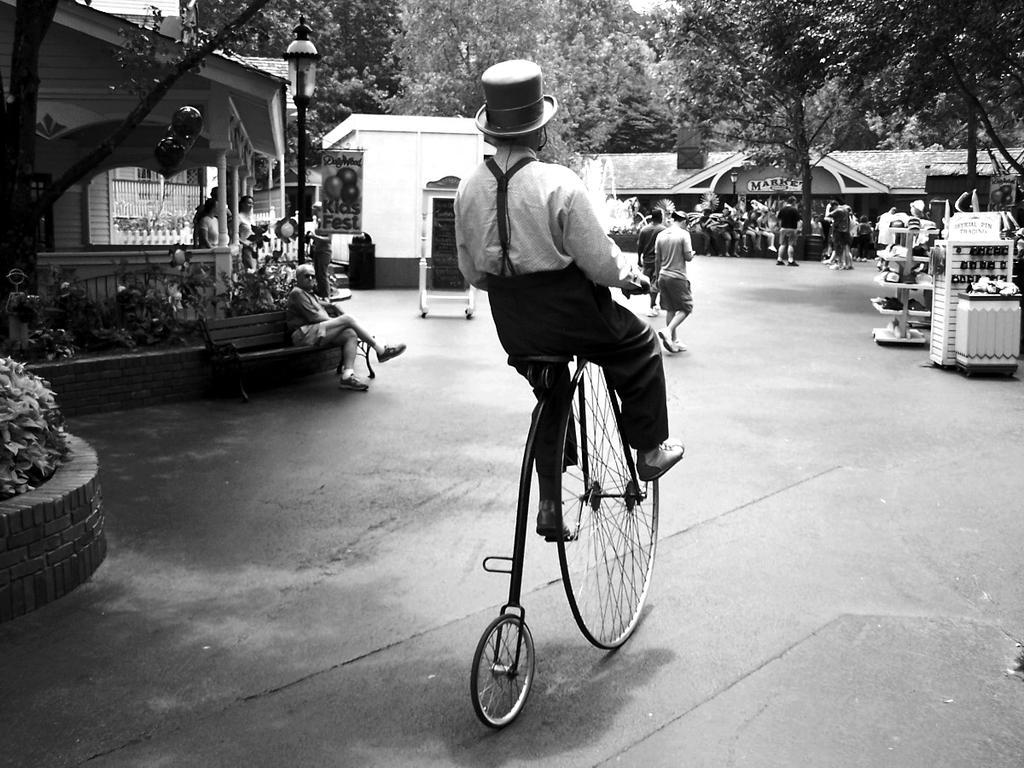Could you give a brief overview of what you see in this image? In this image In the middle there is a man he wear hat, shirt, trouser and shoes he is riding wheel. In the back ground there is a bench, planter, street light, some people,trees, house and road. 